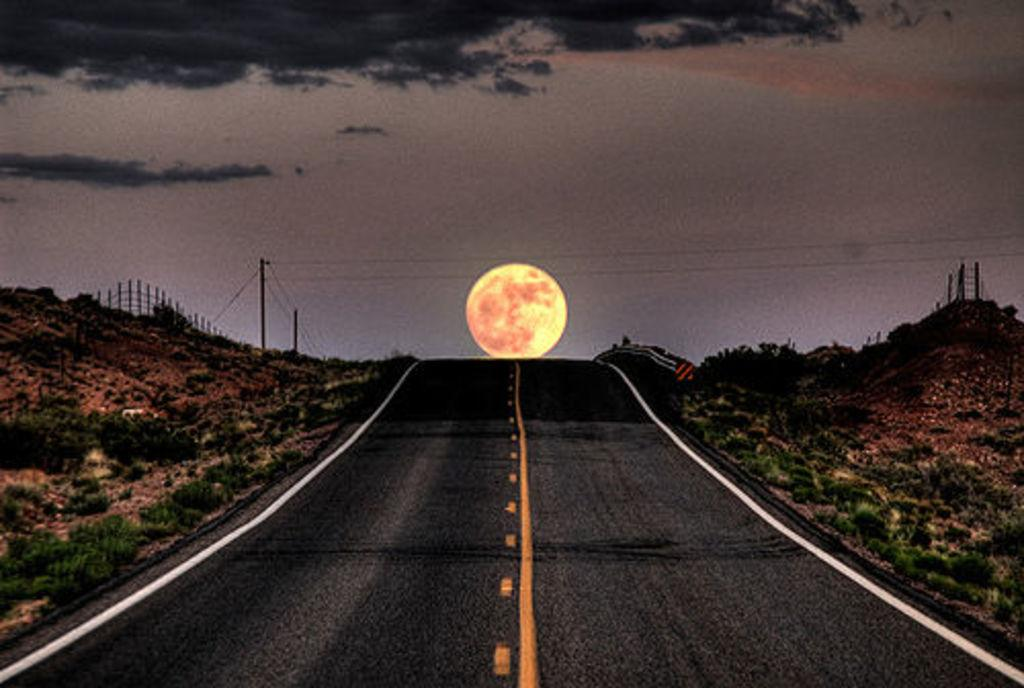What is the main feature of the image? There is a road in the image. What can be seen in the sky? The sun is visible in the sky, and there are also black clouds present. What type of vegetation is growing alongside the road? There are small plants on both sides of the road. Where are the cherries placed on the table in the image? There are no cherries or table present in the image. How many quarters are visible on the road in the image? There are no quarters visible on the road in the image. 